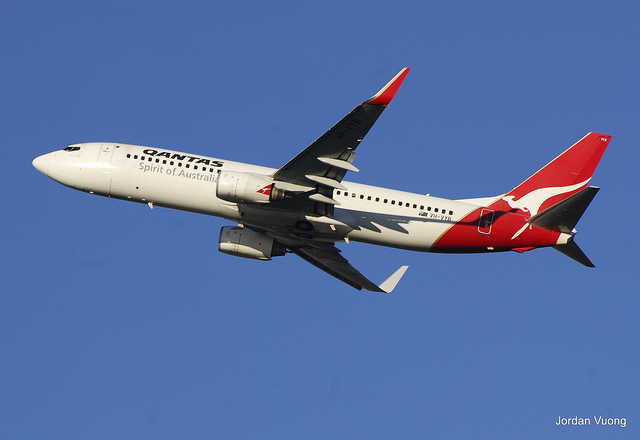Identify the text displayed in this image. QUANTAS Spirit of Australi Vuong Jordan 